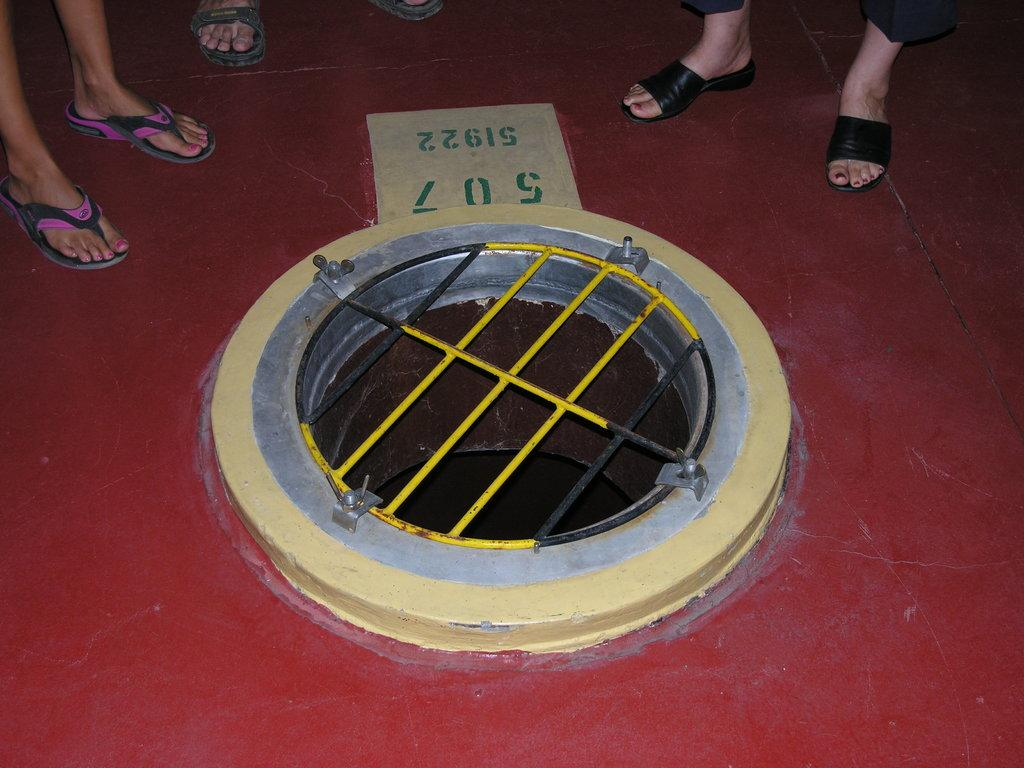What is the main object in the image? There is a manhole in the image. What else can be seen near the manhole? There are rods near the manhole. What other object with numbers is present in the image? There is a board with numbers in the image. Can you see any people in the image? Yes, there are legs of one or more persons visible on the floor. What type of animals can be seen at the zoo in the image? There is no zoo present in the image, so it is not possible to determine what, if any, animals might be seen. 